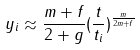Convert formula to latex. <formula><loc_0><loc_0><loc_500><loc_500>y _ { i } \approx \frac { m + f } { 2 + g } ( \frac { t } { t _ { i } } ) ^ { \frac { m } { 2 m + f } }</formula> 